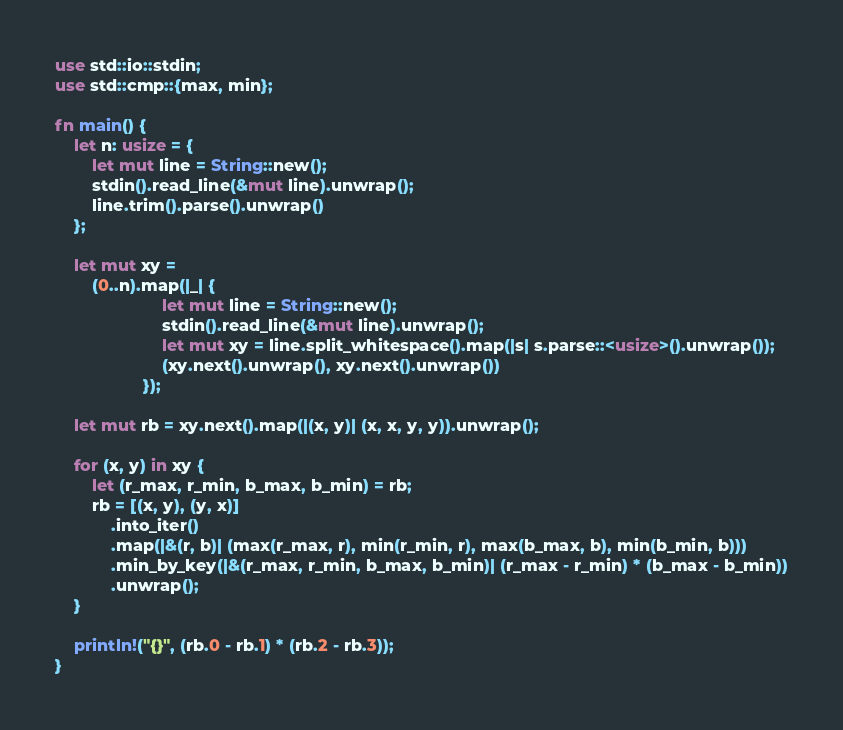Convert code to text. <code><loc_0><loc_0><loc_500><loc_500><_Rust_>use std::io::stdin;
use std::cmp::{max, min};

fn main() {
    let n: usize = {
        let mut line = String::new();
        stdin().read_line(&mut line).unwrap();
        line.trim().parse().unwrap()
    };

    let mut xy =
        (0..n).map(|_| {
                       let mut line = String::new();
                       stdin().read_line(&mut line).unwrap();
                       let mut xy = line.split_whitespace().map(|s| s.parse::<usize>().unwrap());
                       (xy.next().unwrap(), xy.next().unwrap())
                   });

    let mut rb = xy.next().map(|(x, y)| (x, x, y, y)).unwrap();

    for (x, y) in xy {
        let (r_max, r_min, b_max, b_min) = rb;
        rb = [(x, y), (y, x)]
            .into_iter()
            .map(|&(r, b)| (max(r_max, r), min(r_min, r), max(b_max, b), min(b_min, b)))
            .min_by_key(|&(r_max, r_min, b_max, b_min)| (r_max - r_min) * (b_max - b_min))
            .unwrap();
    }

    println!("{}", (rb.0 - rb.1) * (rb.2 - rb.3));
}
</code> 